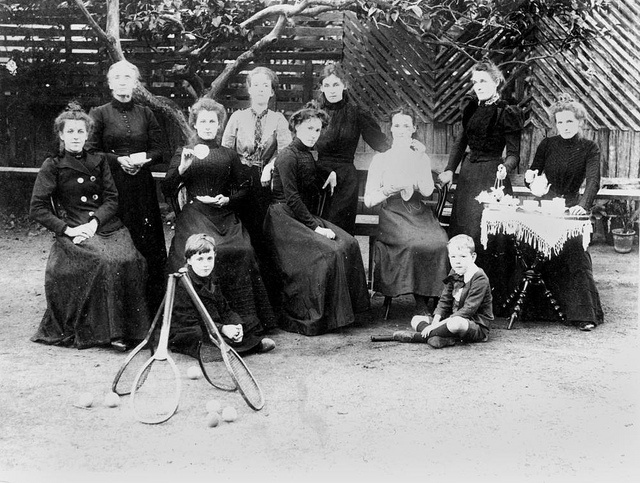Describe the objects in this image and their specific colors. I can see people in darkgray, black, gray, and lightgray tones, people in darkgray, black, lightgray, and gray tones, people in darkgray, black, gray, and lightgray tones, people in darkgray, black, gray, and lightgray tones, and people in darkgray, gray, lightgray, and black tones in this image. 